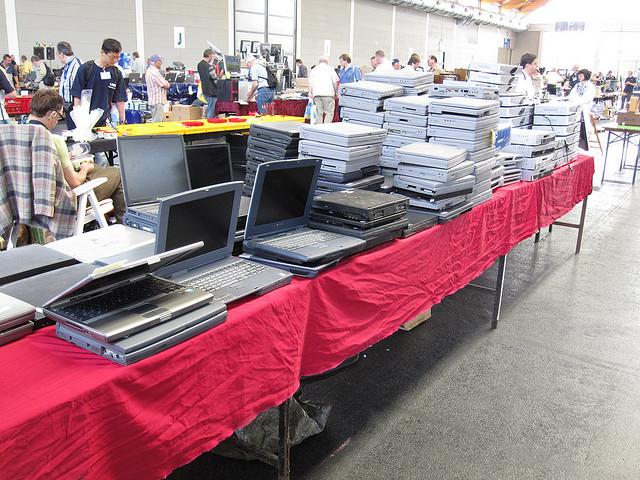Are the computers for sale?
Keep it brief. Yes. Is this a flea market?
Give a very brief answer. Yes. What is on the table?
Write a very short answer. Laptops. 